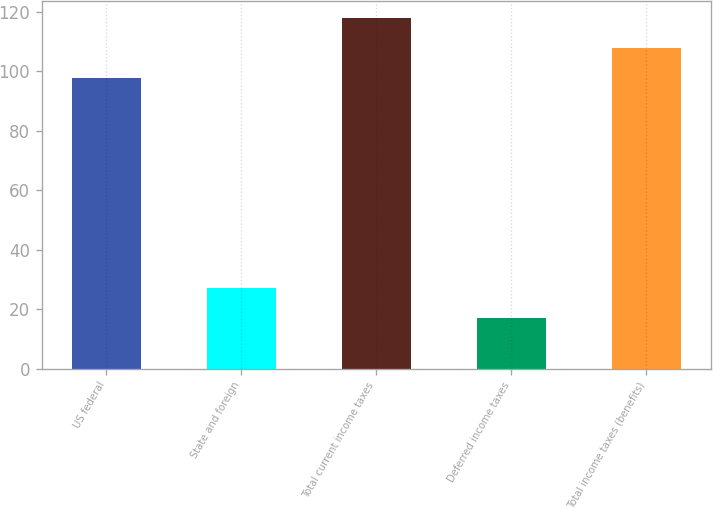<chart> <loc_0><loc_0><loc_500><loc_500><bar_chart><fcel>US federal<fcel>State and foreign<fcel>Total current income taxes<fcel>Deferred income taxes<fcel>Total income taxes (benefits)<nl><fcel>97.7<fcel>27.01<fcel>117.72<fcel>17<fcel>107.71<nl></chart> 